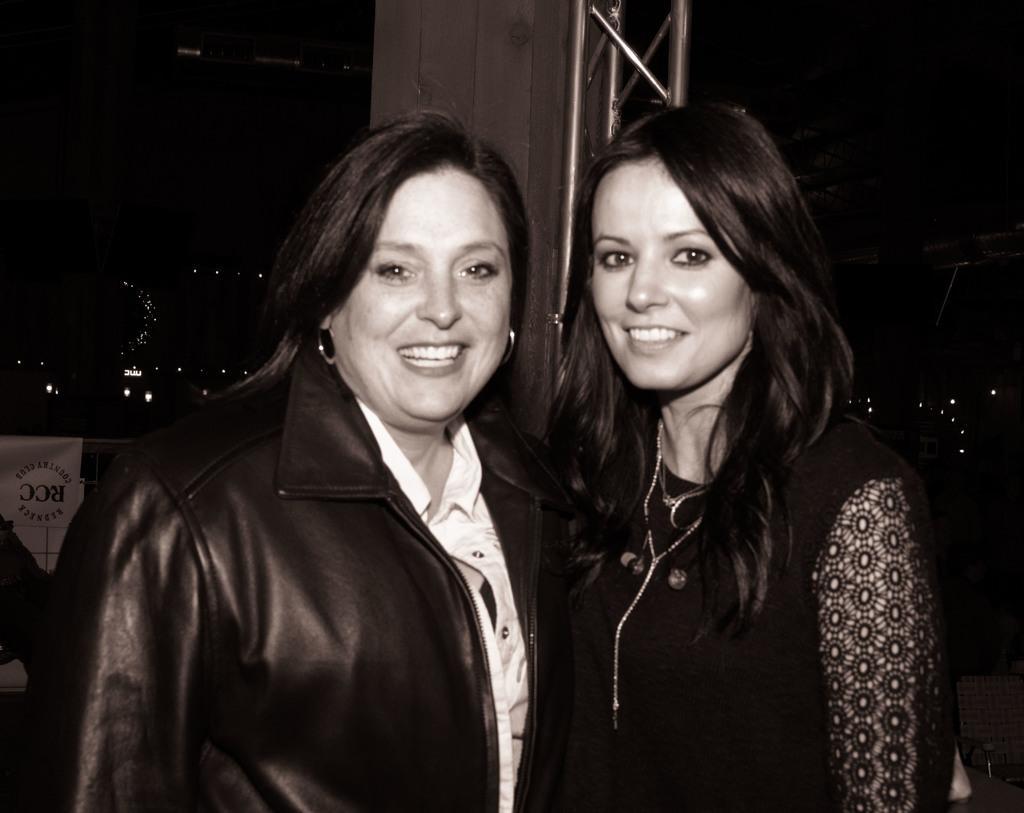Please provide a concise description of this image. In this image we can see two ladies standing and smiling. In the background there is a pillar. On the left there is a banner and we can see lights. 